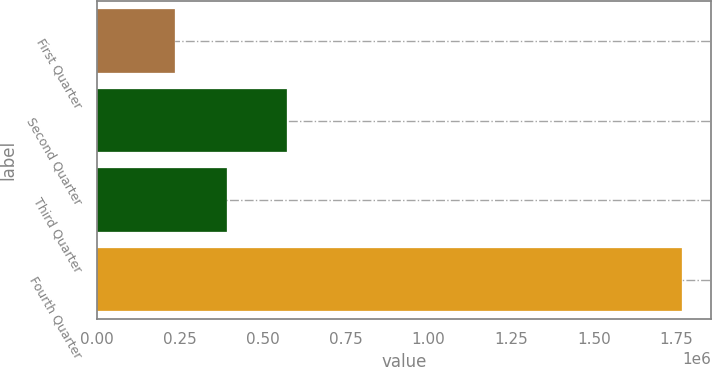Convert chart to OTSL. <chart><loc_0><loc_0><loc_500><loc_500><bar_chart><fcel>First Quarter<fcel>Second Quarter<fcel>Third Quarter<fcel>Fourth Quarter<nl><fcel>235242<fcel>572590<fcel>393204<fcel>1.76554e+06<nl></chart> 